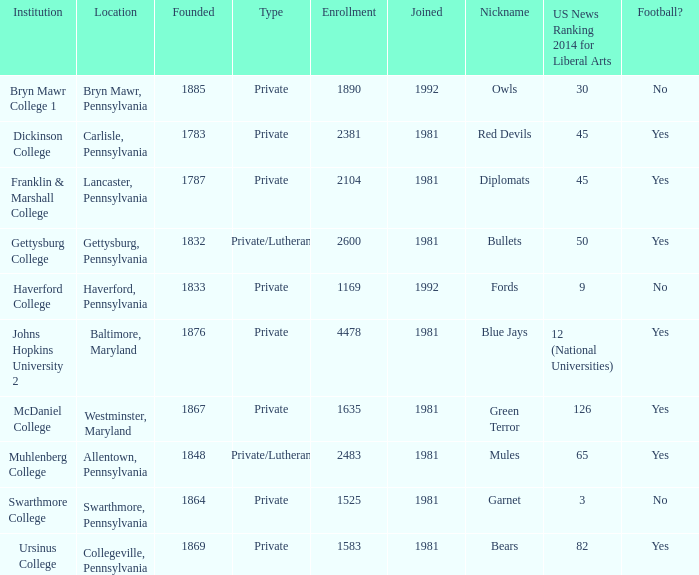When was Dickinson College founded? 1783.0. 